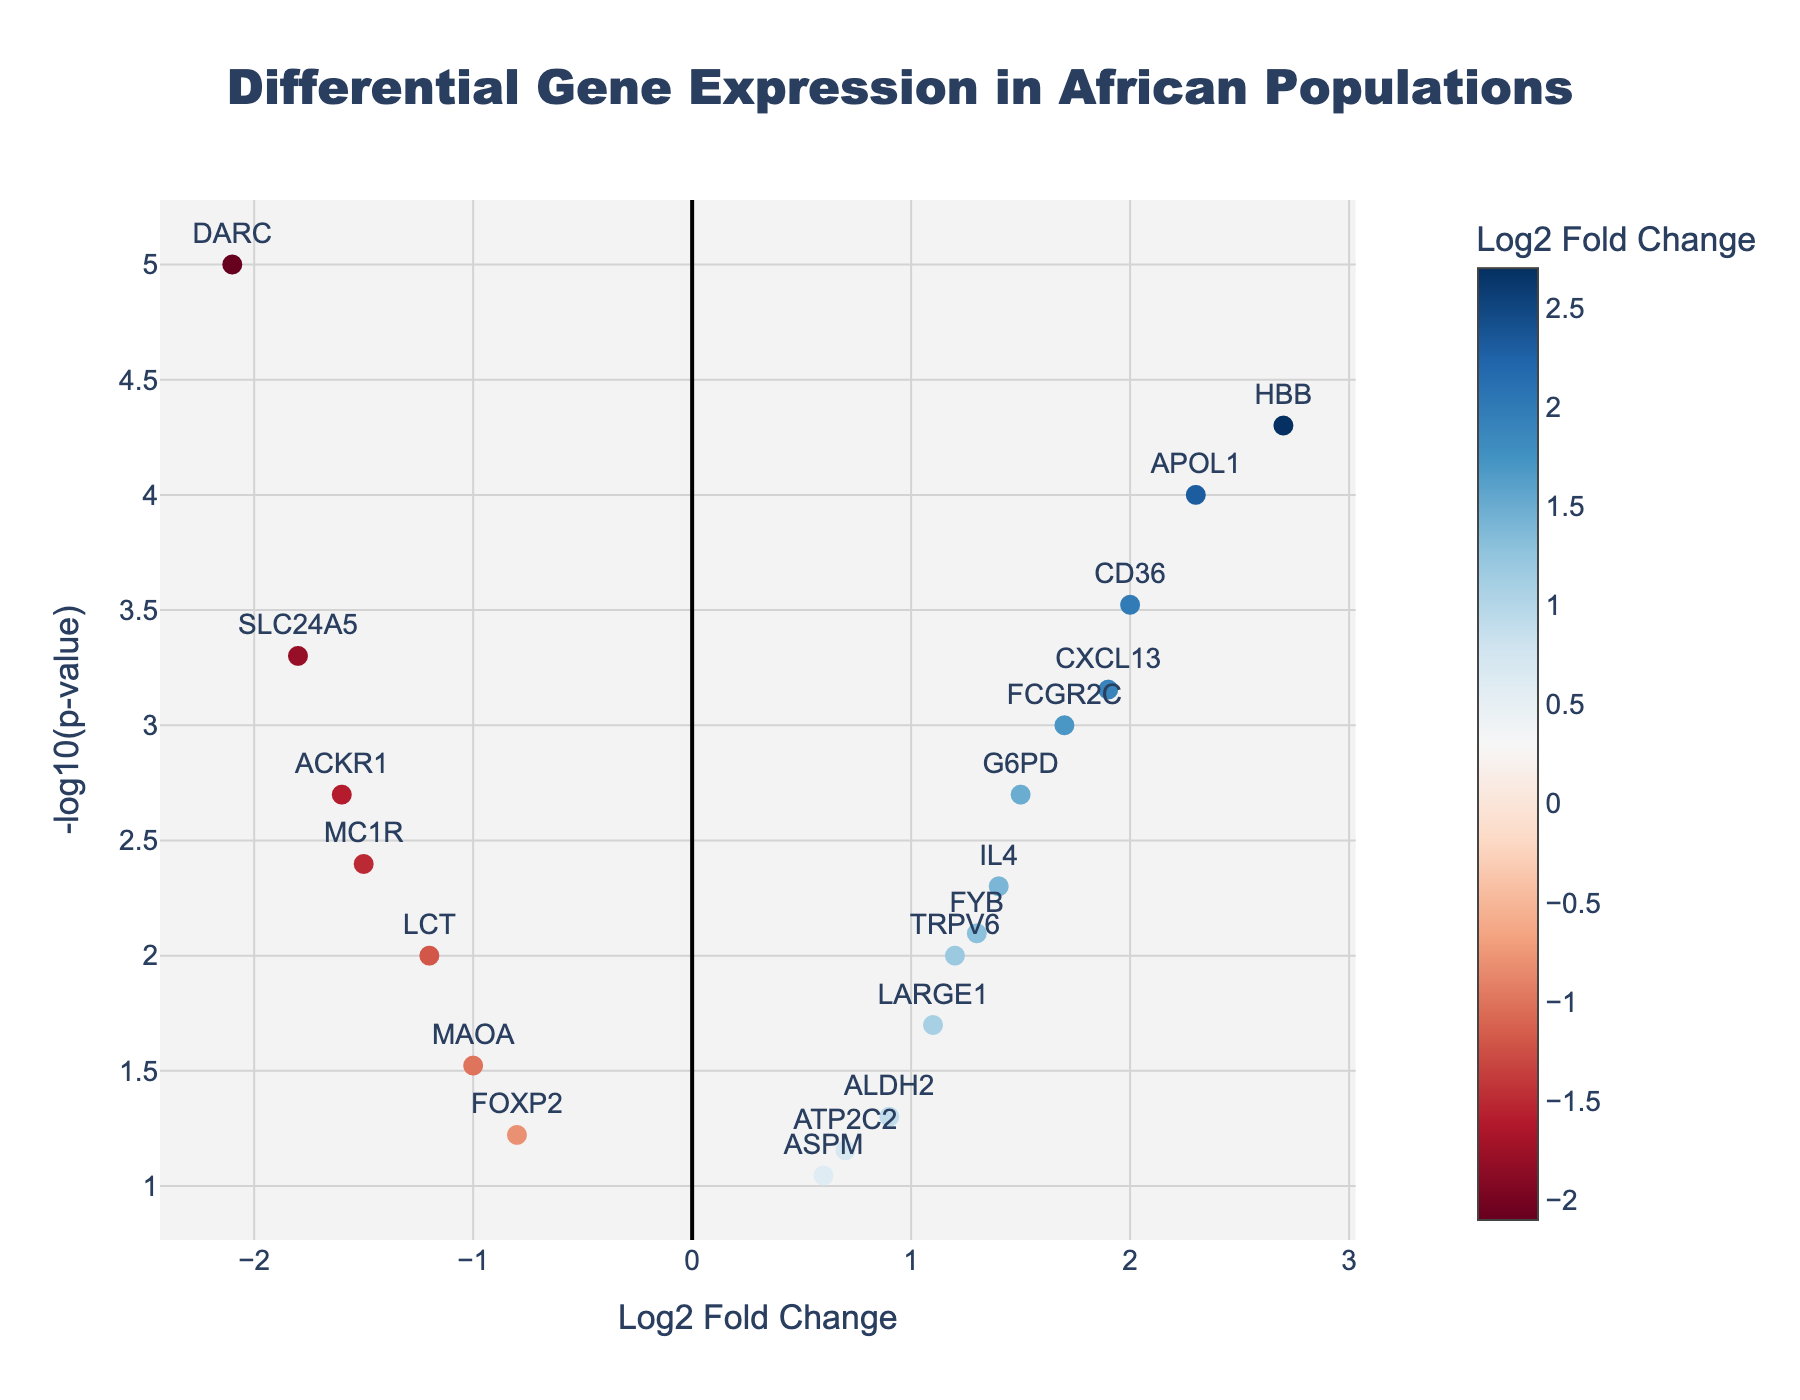What is the title of the figure? The title of the figure can typically be found at the top of the plot, providing a summary of the data represented. In this case, the title is clearly stated at the top.
Answer: Differential Gene Expression in African Populations Which axis represents the Log2 Fold Change? The axis labels describe what each axis represents. The x-axis is labeled "Log2 Fold Change," indicating it represents the Log2 Fold Change.
Answer: x-axis How many genes have a positive Log2 Fold Change? To answer this, count the number of data points (genes) that are located to the right of the y-axis (where Log2 Fold Change is greater than 0). Based on the data, count the genes APOL1, G6PD, HBB, ALDH2, FCGR2C, CD36, FYB, LARGE1, CXCL13, IL4, TRPV6, ASPM.
Answer: 12 Which gene has the most significant p-value? The significance of the p-value is indicated by the -log10(p-value). The gene with the highest y-axis value has the most significant p-value. DARC has the highest -log10(p-value).
Answer: DARC How many genes have a -log10(p-value) greater than 3? Count the number of data points that are above a y-axis value of 3. From the data, consider the genes APOL1, SLC24A5, DARC, HBB, CD36, FCGR2C, CXCL13.
Answer: 7 Which gene has the highest Log2 Fold Change? Look for the gene that is farthest to the right on the x-axis. HBB has the highest Log2 Fold Change at 2.7.
Answer: HBB Which gene shows both a large positive Log2 Fold Change and a highly significant p-value? To identify this, look for a gene that is far to the right on the x-axis and high on the y-axis. APOL1 and HBB fit this description as they show high Log2 Fold Change and high -log10(p-value).
Answer: APOL1, HBB Compare APOL1 and DARC based on their fold change and p-value. Which one has a higher fold change, and which one is more significant? Check the x-axis for fold change and the y-axis for -log10(p-value). APOL1 has a higher fold change (2.3 vs -2.1), but DARC is more significant due to a higher -log10(p-value) value.
Answer: APOL1 for fold change, DARC for significance Which gene is the least significant according to the plot? The least significant gene will have the lowest -log10(p-value), which is the gene closest to the x-axis. ASPM has the lowest -log10(p-value) at 0.09.
Answer: ASPM How is the color of the markers determined in the figure? In the plot, the markers' colors are determined by their Log2 Fold Change, with a colorscale indicating the value. Higher and lower fold changes have different colors according to the 'RdBu' colorscale.
Answer: By Log2 Fold Change 